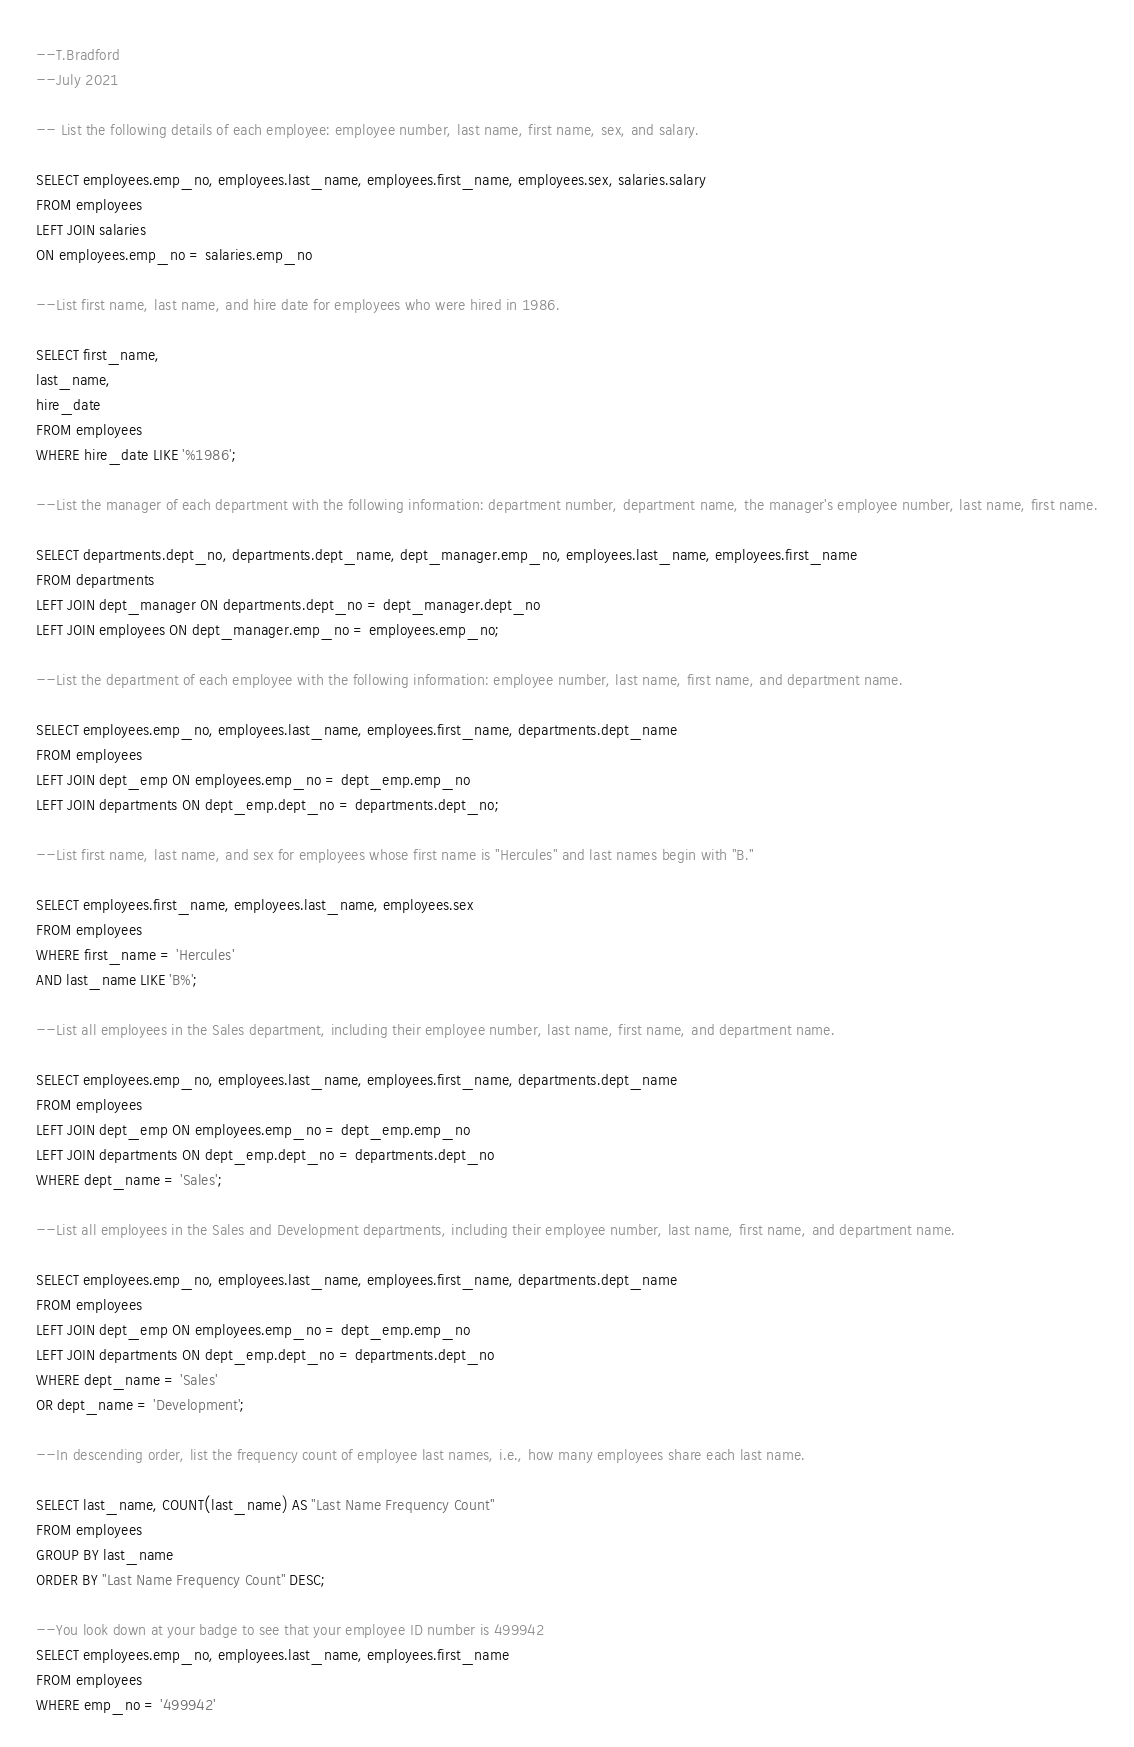Convert code to text. <code><loc_0><loc_0><loc_500><loc_500><_SQL_>--T.Bradford
--July 2021

-- List the following details of each employee: employee number, last name, first name, sex, and salary.

SELECT employees.emp_no, employees.last_name, employees.first_name, employees.sex, salaries.salary
FROM employees
LEFT JOIN salaries
ON employees.emp_no = salaries.emp_no

--List first name, last name, and hire date for employees who were hired in 1986.

SELECT first_name, 
last_name, 
hire_date
FROM employees
WHERE hire_date LIKE '%1986';

--List the manager of each department with the following information: department number, department name, the manager's employee number, last name, first name.

SELECT departments.dept_no, departments.dept_name, dept_manager.emp_no, employees.last_name, employees.first_name
FROM departments
LEFT JOIN dept_manager ON departments.dept_no = dept_manager.dept_no
LEFT JOIN employees ON dept_manager.emp_no = employees.emp_no;

--List the department of each employee with the following information: employee number, last name, first name, and department name.

SELECT employees.emp_no, employees.last_name, employees.first_name, departments.dept_name
FROM employees
LEFT JOIN dept_emp ON employees.emp_no = dept_emp.emp_no
LEFT JOIN departments ON dept_emp.dept_no = departments.dept_no;

--List first name, last name, and sex for employees whose first name is "Hercules" and last names begin with "B."

SELECT employees.first_name, employees.last_name, employees.sex
FROM employees
WHERE first_name = 'Hercules'
AND last_name LIKE 'B%';

--List all employees in the Sales department, including their employee number, last name, first name, and department name.

SELECT employees.emp_no, employees.last_name, employees.first_name, departments.dept_name
FROM employees
LEFT JOIN dept_emp ON employees.emp_no = dept_emp.emp_no
LEFT JOIN departments ON dept_emp.dept_no = departments.dept_no
WHERE dept_name = 'Sales';

--List all employees in the Sales and Development departments, including their employee number, last name, first name, and department name.

SELECT employees.emp_no, employees.last_name, employees.first_name, departments.dept_name
FROM employees
LEFT JOIN dept_emp ON employees.emp_no = dept_emp.emp_no
LEFT JOIN departments ON dept_emp.dept_no = departments.dept_no
WHERE dept_name = 'Sales'
OR dept_name = 'Development';

--In descending order, list the frequency count of employee last names, i.e., how many employees share each last name.

SELECT last_name, COUNT(last_name) AS "Last Name Frequency Count"
FROM employees
GROUP BY last_name
ORDER BY "Last Name Frequency Count" DESC;

--You look down at your badge to see that your employee ID number is 499942
SELECT employees.emp_no, employees.last_name, employees.first_name
FROM employees
WHERE emp_no = '499942'</code> 